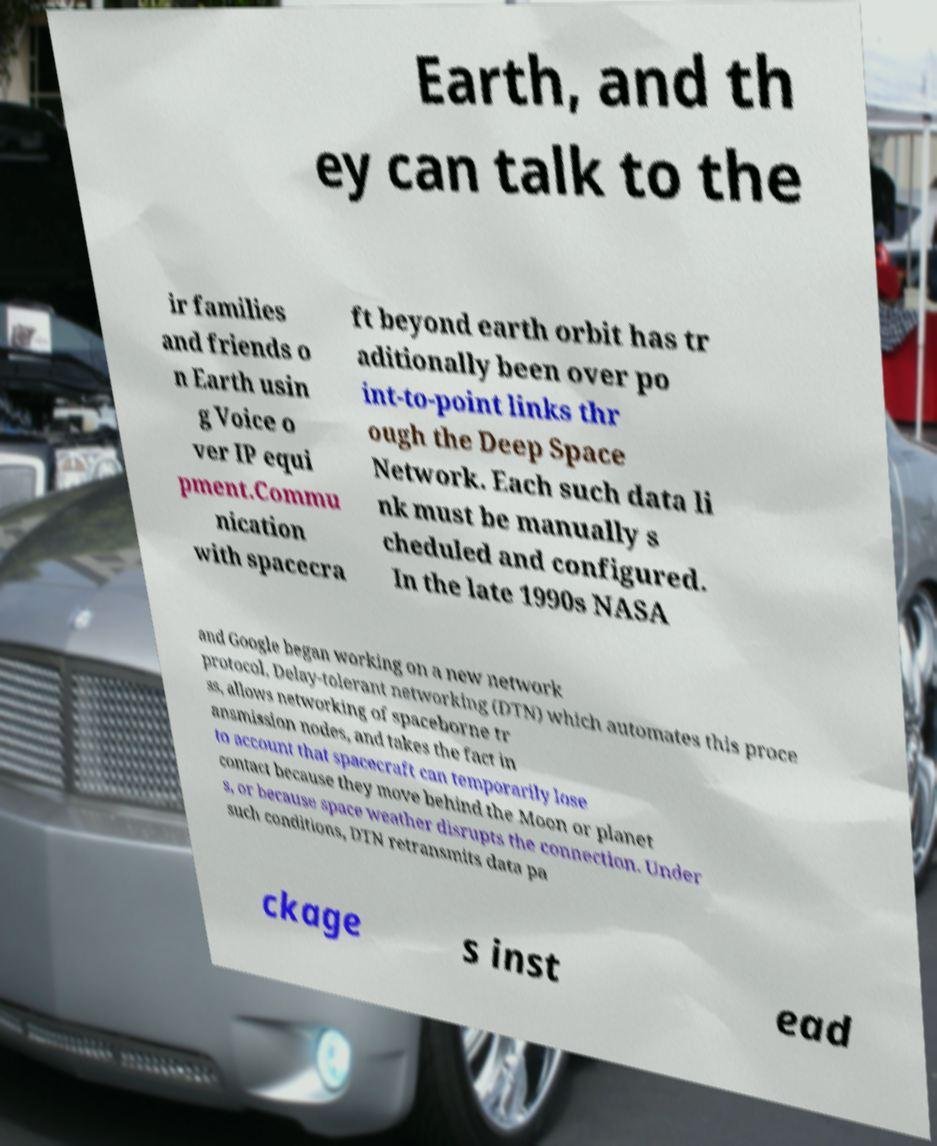What messages or text are displayed in this image? I need them in a readable, typed format. Earth, and th ey can talk to the ir families and friends o n Earth usin g Voice o ver IP equi pment.Commu nication with spacecra ft beyond earth orbit has tr aditionally been over po int-to-point links thr ough the Deep Space Network. Each such data li nk must be manually s cheduled and configured. In the late 1990s NASA and Google began working on a new network protocol, Delay-tolerant networking (DTN) which automates this proce ss, allows networking of spaceborne tr ansmission nodes, and takes the fact in to account that spacecraft can temporarily lose contact because they move behind the Moon or planet s, or because space weather disrupts the connection. Under such conditions, DTN retransmits data pa ckage s inst ead 